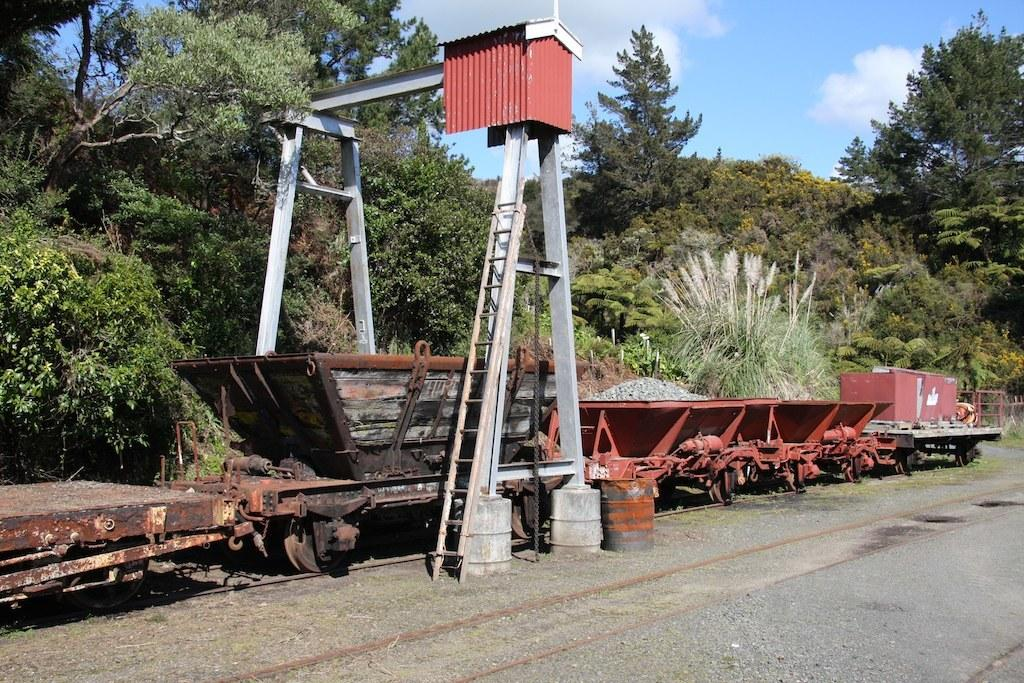What type of transportation infrastructure is present in the image? There are railway tracks in the image. What vehicles are using the railway tracks? There are railway trolleys in the image. What natural elements can be seen in the image? Trees and clouds are visible in the image. What part of the sky is visible in the image? The sky is visible in the image. What additional object can be seen in the image? There is a ladder in the image. What type of pancake is being served to the lawyer in the image? There is no pancake or lawyer present in the image. How does the wealth of the person in the image compare to their neighbor's? There is no indication of wealth or neighbors in the image. 